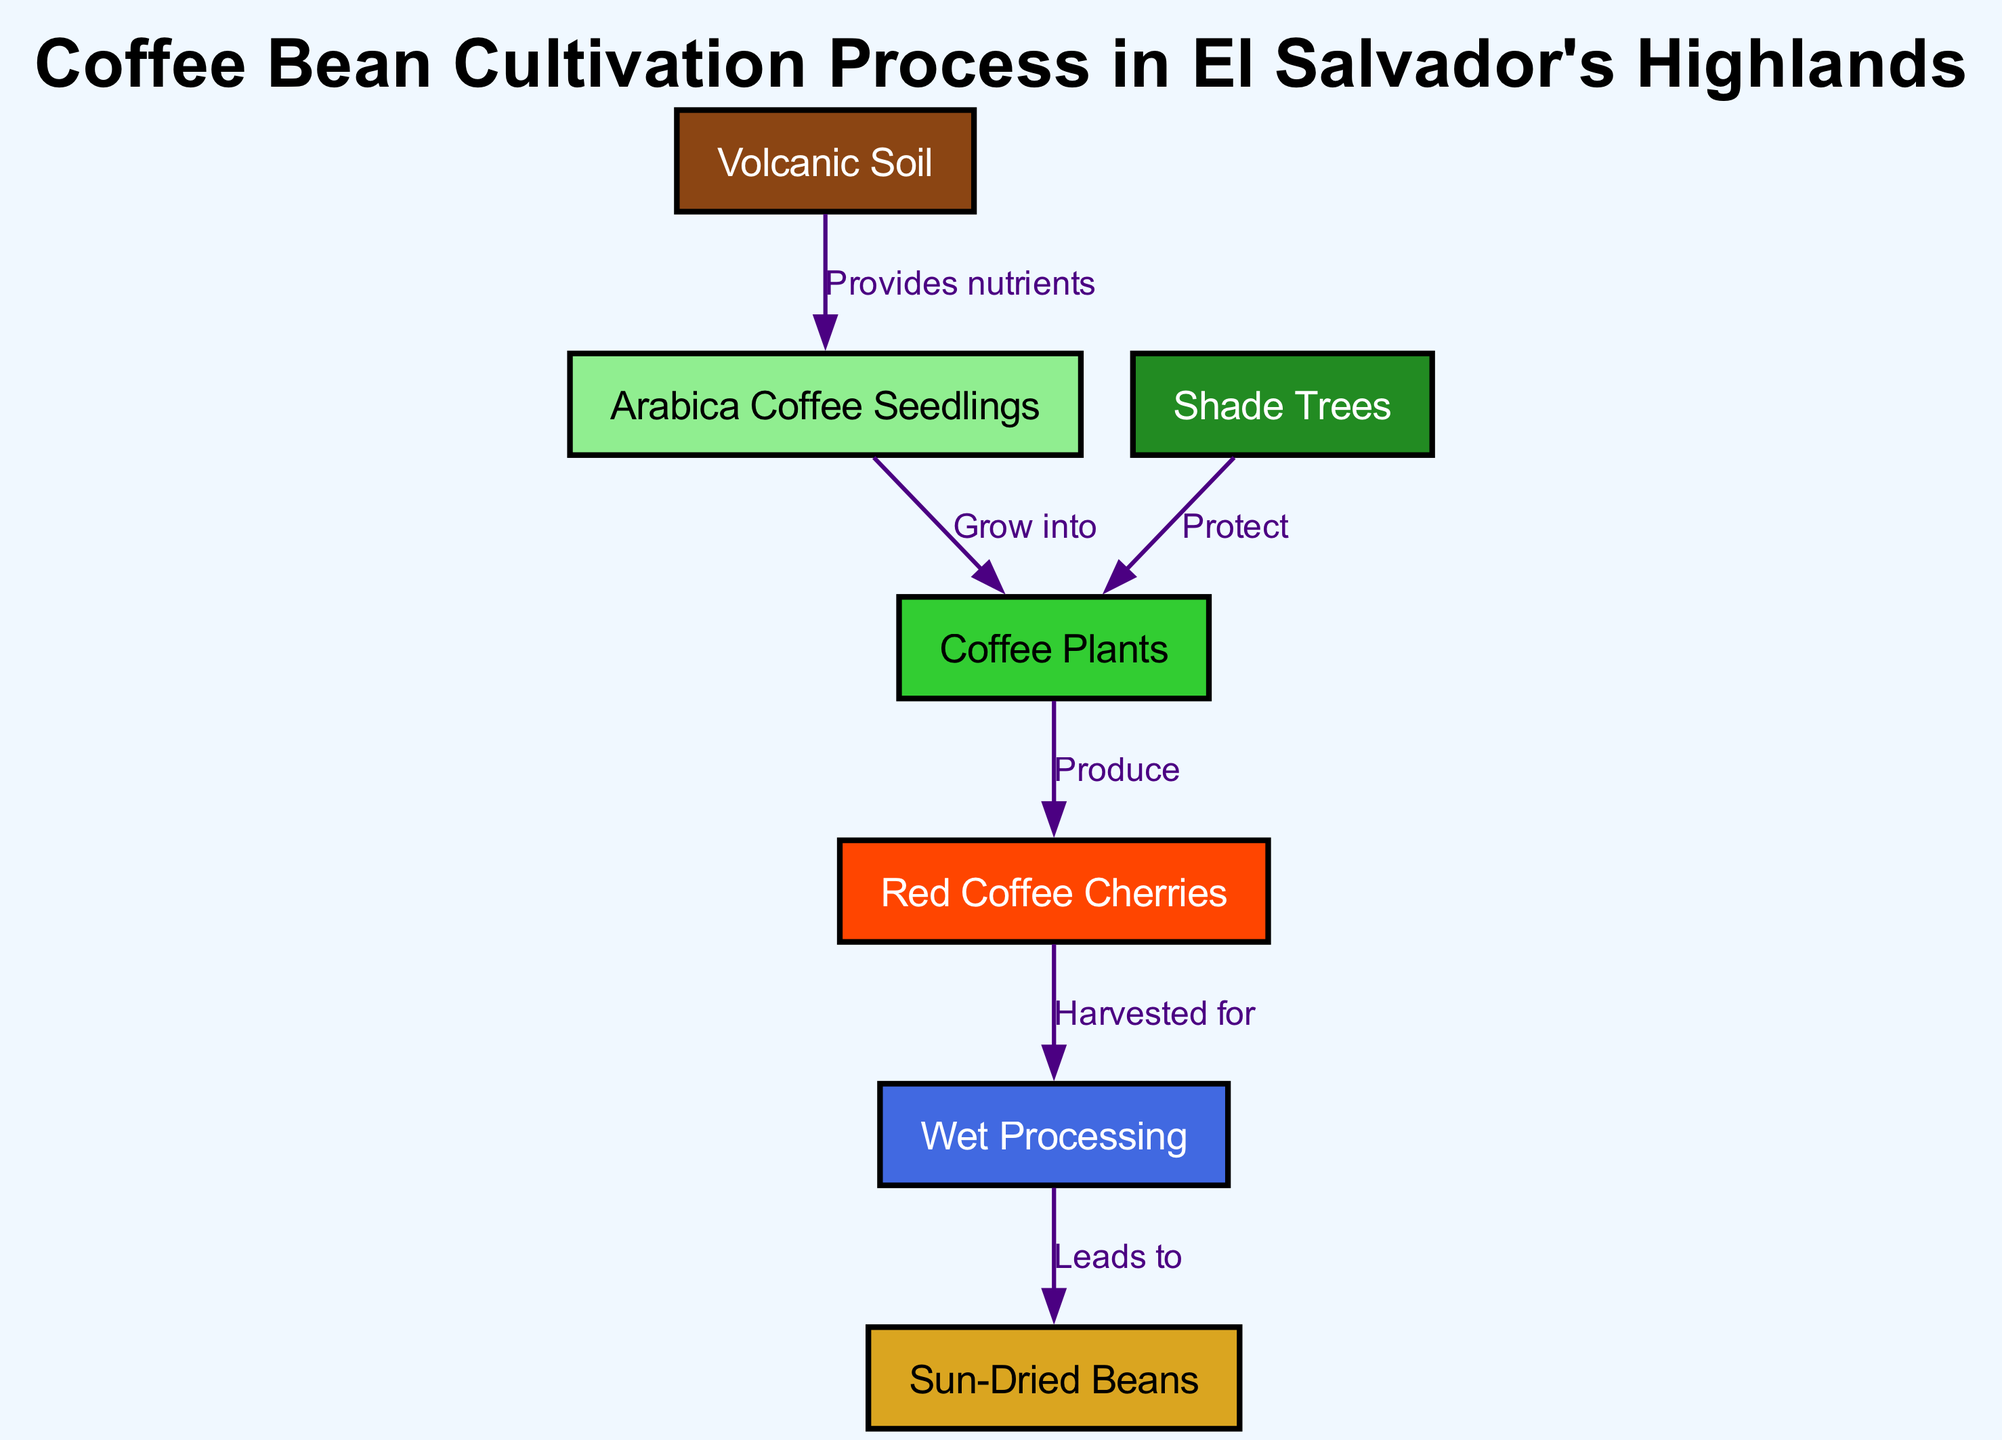What is the first step in coffee cultivation according to the diagram? The diagram indicates that "Volcanic Soil" is the first node since it provides the necessary nutrients for Arabica coffee seedlings, which is the next step in the cultivation process.
Answer: Volcanic Soil How many nodes are present in the diagram? By counting each individual node listed in the data, there are a total of seven nodes representing different stages and elements in the coffee cultivation process.
Answer: Seven What do shade trees do in the cultivation process? The diagram shows that "Shade Trees" protect the "Coffee Plants," indicating their role in providing shelter and favorable growing conditions for the plants.
Answer: Protect What do red coffee cherries represent in the process? "Red Coffee Cherries" are the nodes that represent the product of the coffee plants after they have matured and produced coffee cherries, indicating a stage in the cultivation process.
Answer: Produce What leads to sun-dried beans after processing? The diagram establishes that "Wet Processing" leads to "Sun-Dried Beans," demonstrating that this is the final step following the harvesting of red coffee cherries.
Answer: Wet Processing Which nodes are directly connected to coffee plants? The nodes directly connected to "Coffee Plants" are "Arabica Coffee Seedlings" and "Shade Trees," which indicate what contributes to their growth and protection.
Answer: Arabica Coffee Seedlings and Shade Trees How does the process start, according to the diagram? The process starts with "Volcanic Soil," which nurtures the seedlings, leading to the development of coffee plants in subsequent steps.
Answer: Volcanic Soil What stage comes after harvesting red coffee cherries? According to the diagram, the stage that comes after harvesting "Red Coffee Cherries" is "Wet Processing," which is necessary to prepare the cherries for drying.
Answer: Wet Processing 